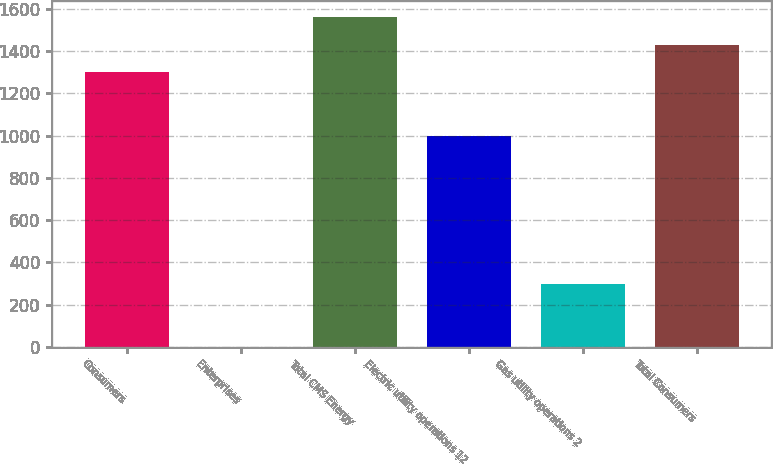Convert chart. <chart><loc_0><loc_0><loc_500><loc_500><bar_chart><fcel>Consumers<fcel>Enterprises<fcel>Total CMS Energy<fcel>Electric utility operations 12<fcel>Gas utility operations 2<fcel>Total Consumers<nl><fcel>1300<fcel>1<fcel>1560<fcel>1000<fcel>300<fcel>1430<nl></chart> 